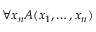<formula> <loc_0><loc_0><loc_500><loc_500>\forall x _ { n } A ( x _ { 1 } , \dots , x _ { n } )</formula> 